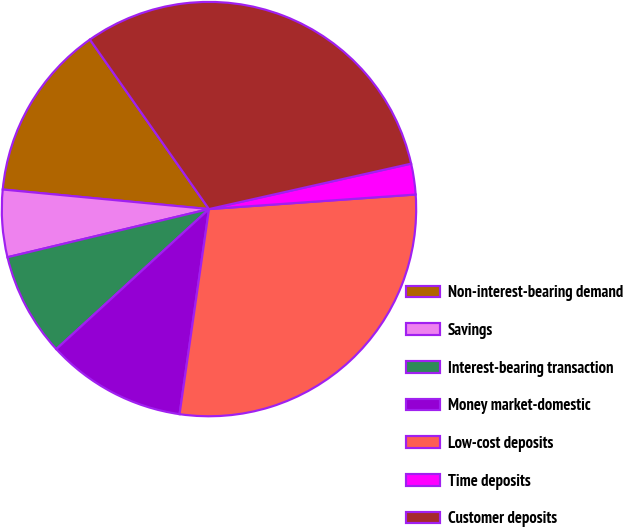<chart> <loc_0><loc_0><loc_500><loc_500><pie_chart><fcel>Non-interest-bearing demand<fcel>Savings<fcel>Interest-bearing transaction<fcel>Money market-domestic<fcel>Low-cost deposits<fcel>Time deposits<fcel>Customer deposits<nl><fcel>13.75%<fcel>5.24%<fcel>8.08%<fcel>10.92%<fcel>28.39%<fcel>2.4%<fcel>31.23%<nl></chart> 